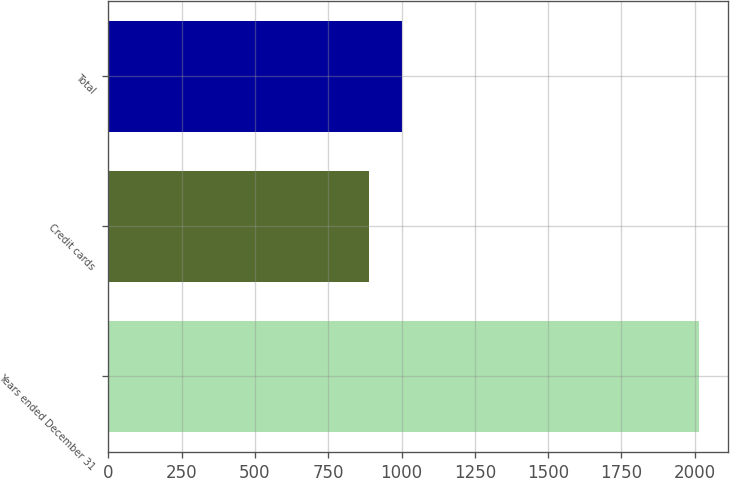Convert chart to OTSL. <chart><loc_0><loc_0><loc_500><loc_500><bar_chart><fcel>Years ended December 31<fcel>Credit cards<fcel>Total<nl><fcel>2013<fcel>890<fcel>1002.3<nl></chart> 